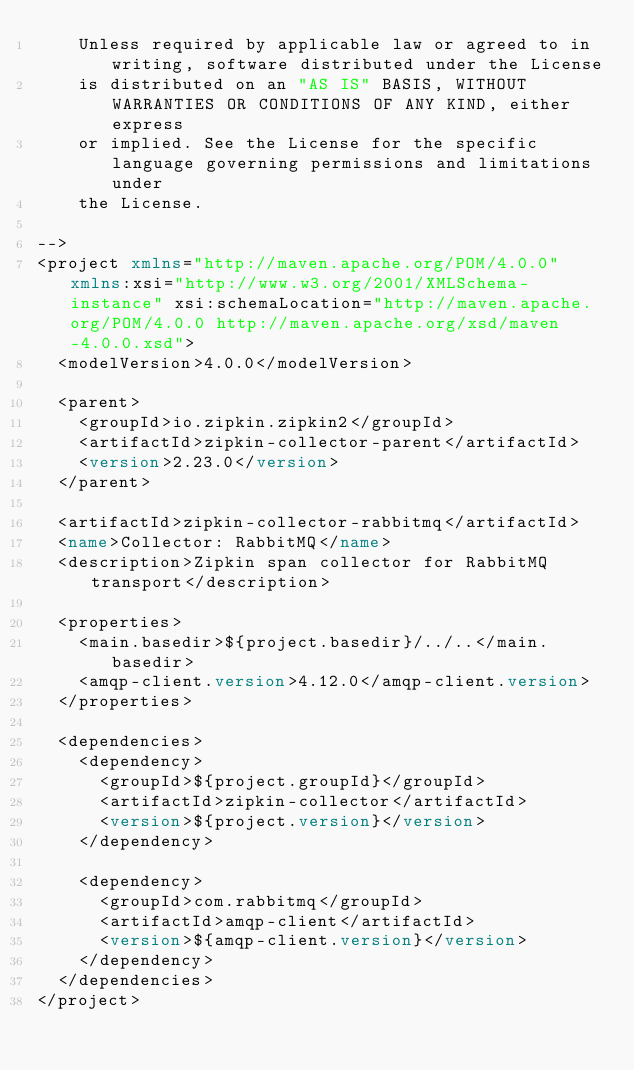Convert code to text. <code><loc_0><loc_0><loc_500><loc_500><_XML_>    Unless required by applicable law or agreed to in writing, software distributed under the License
    is distributed on an "AS IS" BASIS, WITHOUT WARRANTIES OR CONDITIONS OF ANY KIND, either express
    or implied. See the License for the specific language governing permissions and limitations under
    the License.

-->
<project xmlns="http://maven.apache.org/POM/4.0.0" xmlns:xsi="http://www.w3.org/2001/XMLSchema-instance" xsi:schemaLocation="http://maven.apache.org/POM/4.0.0 http://maven.apache.org/xsd/maven-4.0.0.xsd">
  <modelVersion>4.0.0</modelVersion>

  <parent>
    <groupId>io.zipkin.zipkin2</groupId>
    <artifactId>zipkin-collector-parent</artifactId>
    <version>2.23.0</version>
  </parent>

  <artifactId>zipkin-collector-rabbitmq</artifactId>
  <name>Collector: RabbitMQ</name>
  <description>Zipkin span collector for RabbitMQ transport</description>

  <properties>
    <main.basedir>${project.basedir}/../..</main.basedir>
    <amqp-client.version>4.12.0</amqp-client.version>
  </properties>

  <dependencies>
    <dependency>
      <groupId>${project.groupId}</groupId>
      <artifactId>zipkin-collector</artifactId>
      <version>${project.version}</version>
    </dependency>

    <dependency>
      <groupId>com.rabbitmq</groupId>
      <artifactId>amqp-client</artifactId>
      <version>${amqp-client.version}</version>
    </dependency>
  </dependencies>
</project>
</code> 